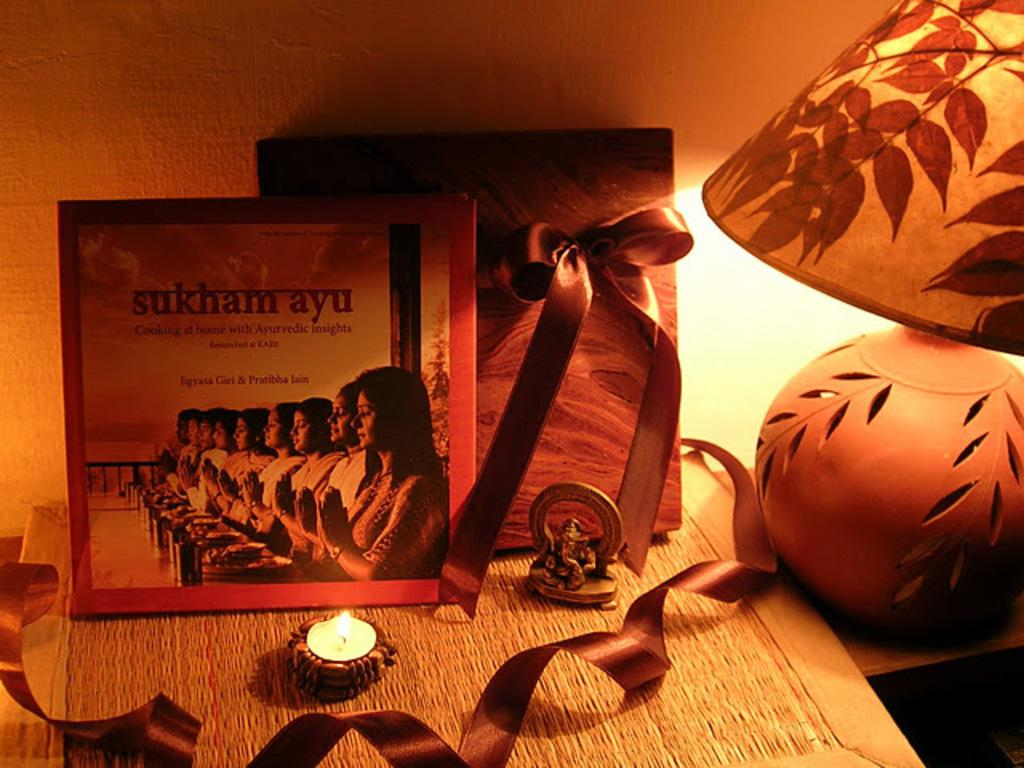What piece of furniture is present in the image? There is a table in the image. What is placed on the table? There is a candle, an idol, and photo frames on the table. What type of lighting is present on the table? There is a table lamp beside the table. Can you describe the lighting in the background? There is a table lamp in the background. How many cows are visible in the image? There are no cows present in the image. What type of tool is used to measure weight in the image? There is no scale present in the image. 